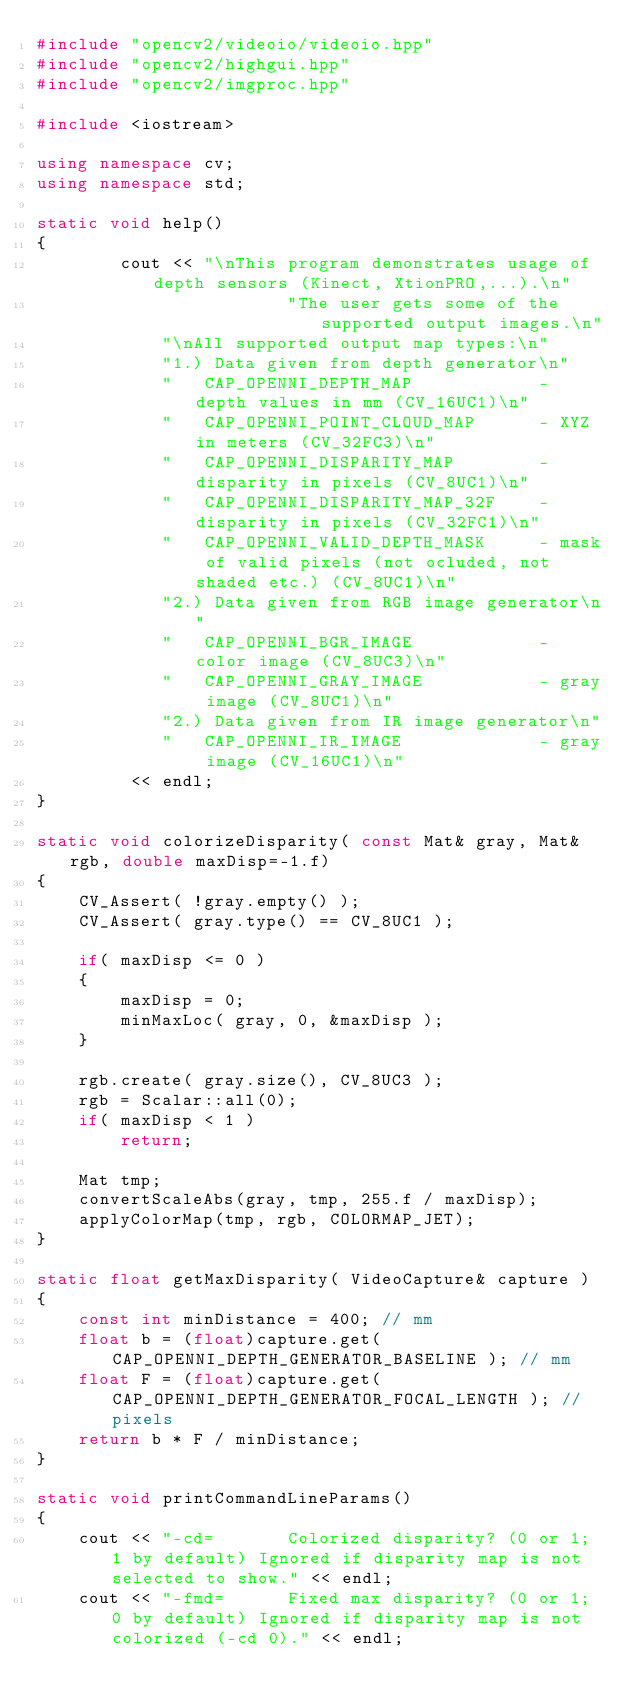<code> <loc_0><loc_0><loc_500><loc_500><_C++_>#include "opencv2/videoio/videoio.hpp"
#include "opencv2/highgui.hpp"
#include "opencv2/imgproc.hpp"

#include <iostream>

using namespace cv;
using namespace std;

static void help()
{
        cout << "\nThis program demonstrates usage of depth sensors (Kinect, XtionPRO,...).\n"
                        "The user gets some of the supported output images.\n"
            "\nAll supported output map types:\n"
            "1.) Data given from depth generator\n"
            "   CAP_OPENNI_DEPTH_MAP            - depth values in mm (CV_16UC1)\n"
            "   CAP_OPENNI_POINT_CLOUD_MAP      - XYZ in meters (CV_32FC3)\n"
            "   CAP_OPENNI_DISPARITY_MAP        - disparity in pixels (CV_8UC1)\n"
            "   CAP_OPENNI_DISPARITY_MAP_32F    - disparity in pixels (CV_32FC1)\n"
            "   CAP_OPENNI_VALID_DEPTH_MASK     - mask of valid pixels (not ocluded, not shaded etc.) (CV_8UC1)\n"
            "2.) Data given from RGB image generator\n"
            "   CAP_OPENNI_BGR_IMAGE            - color image (CV_8UC3)\n"
            "   CAP_OPENNI_GRAY_IMAGE           - gray image (CV_8UC1)\n"
            "2.) Data given from IR image generator\n"
            "   CAP_OPENNI_IR_IMAGE             - gray image (CV_16UC1)\n"
         << endl;
}

static void colorizeDisparity( const Mat& gray, Mat& rgb, double maxDisp=-1.f)
{
    CV_Assert( !gray.empty() );
    CV_Assert( gray.type() == CV_8UC1 );

    if( maxDisp <= 0 )
    {
        maxDisp = 0;
        minMaxLoc( gray, 0, &maxDisp );
    }

    rgb.create( gray.size(), CV_8UC3 );
    rgb = Scalar::all(0);
    if( maxDisp < 1 )
        return;

    Mat tmp;
    convertScaleAbs(gray, tmp, 255.f / maxDisp);
    applyColorMap(tmp, rgb, COLORMAP_JET);
}

static float getMaxDisparity( VideoCapture& capture )
{
    const int minDistance = 400; // mm
    float b = (float)capture.get( CAP_OPENNI_DEPTH_GENERATOR_BASELINE ); // mm
    float F = (float)capture.get( CAP_OPENNI_DEPTH_GENERATOR_FOCAL_LENGTH ); // pixels
    return b * F / minDistance;
}

static void printCommandLineParams()
{
    cout << "-cd=       Colorized disparity? (0 or 1; 1 by default) Ignored if disparity map is not selected to show." << endl;
    cout << "-fmd=      Fixed max disparity? (0 or 1; 0 by default) Ignored if disparity map is not colorized (-cd 0)." << endl;</code> 